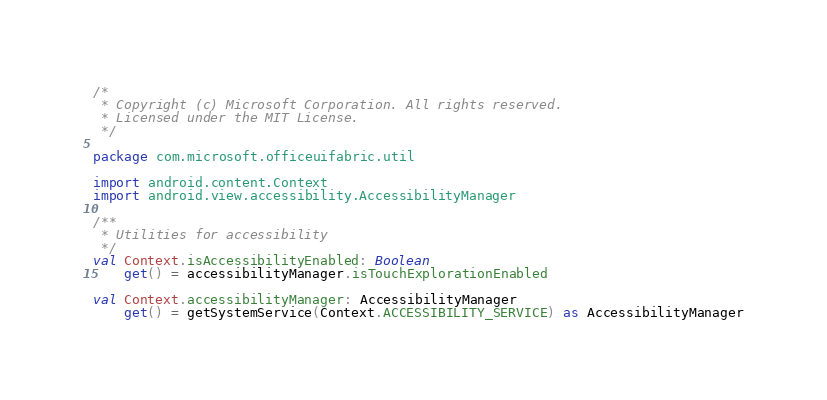<code> <loc_0><loc_0><loc_500><loc_500><_Kotlin_>/*
 * Copyright (c) Microsoft Corporation. All rights reserved.
 * Licensed under the MIT License.
 */

package com.microsoft.officeuifabric.util

import android.content.Context
import android.view.accessibility.AccessibilityManager

/**
 * Utilities for accessibility
 */
val Context.isAccessibilityEnabled: Boolean
    get() = accessibilityManager.isTouchExplorationEnabled

val Context.accessibilityManager: AccessibilityManager
    get() = getSystemService(Context.ACCESSIBILITY_SERVICE) as AccessibilityManager
</code> 